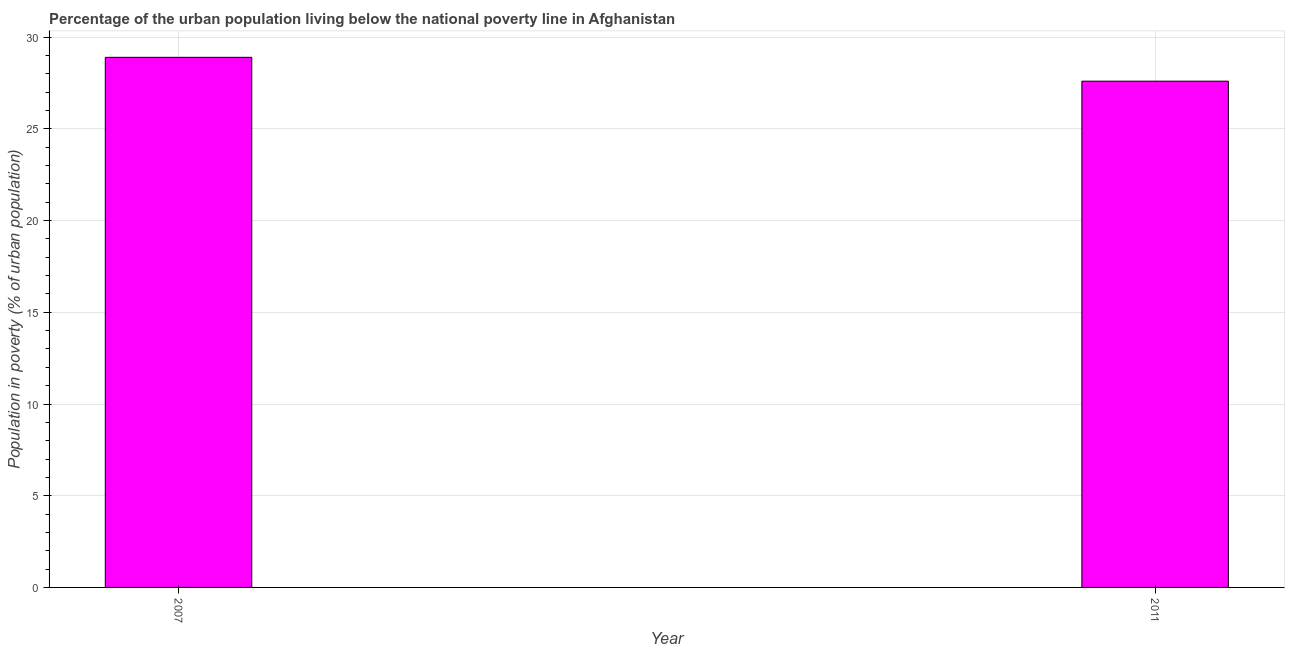Does the graph contain any zero values?
Give a very brief answer. No. Does the graph contain grids?
Ensure brevity in your answer.  Yes. What is the title of the graph?
Your response must be concise. Percentage of the urban population living below the national poverty line in Afghanistan. What is the label or title of the X-axis?
Your answer should be compact. Year. What is the label or title of the Y-axis?
Keep it short and to the point. Population in poverty (% of urban population). What is the percentage of urban population living below poverty line in 2007?
Give a very brief answer. 28.9. Across all years, what is the maximum percentage of urban population living below poverty line?
Provide a short and direct response. 28.9. Across all years, what is the minimum percentage of urban population living below poverty line?
Your response must be concise. 27.6. In which year was the percentage of urban population living below poverty line minimum?
Your response must be concise. 2011. What is the sum of the percentage of urban population living below poverty line?
Keep it short and to the point. 56.5. What is the average percentage of urban population living below poverty line per year?
Make the answer very short. 28.25. What is the median percentage of urban population living below poverty line?
Your answer should be compact. 28.25. What is the ratio of the percentage of urban population living below poverty line in 2007 to that in 2011?
Your answer should be compact. 1.05. Is the percentage of urban population living below poverty line in 2007 less than that in 2011?
Ensure brevity in your answer.  No. What is the difference between two consecutive major ticks on the Y-axis?
Your answer should be compact. 5. What is the Population in poverty (% of urban population) in 2007?
Offer a very short reply. 28.9. What is the Population in poverty (% of urban population) of 2011?
Your answer should be very brief. 27.6. What is the difference between the Population in poverty (% of urban population) in 2007 and 2011?
Your answer should be compact. 1.3. What is the ratio of the Population in poverty (% of urban population) in 2007 to that in 2011?
Offer a very short reply. 1.05. 